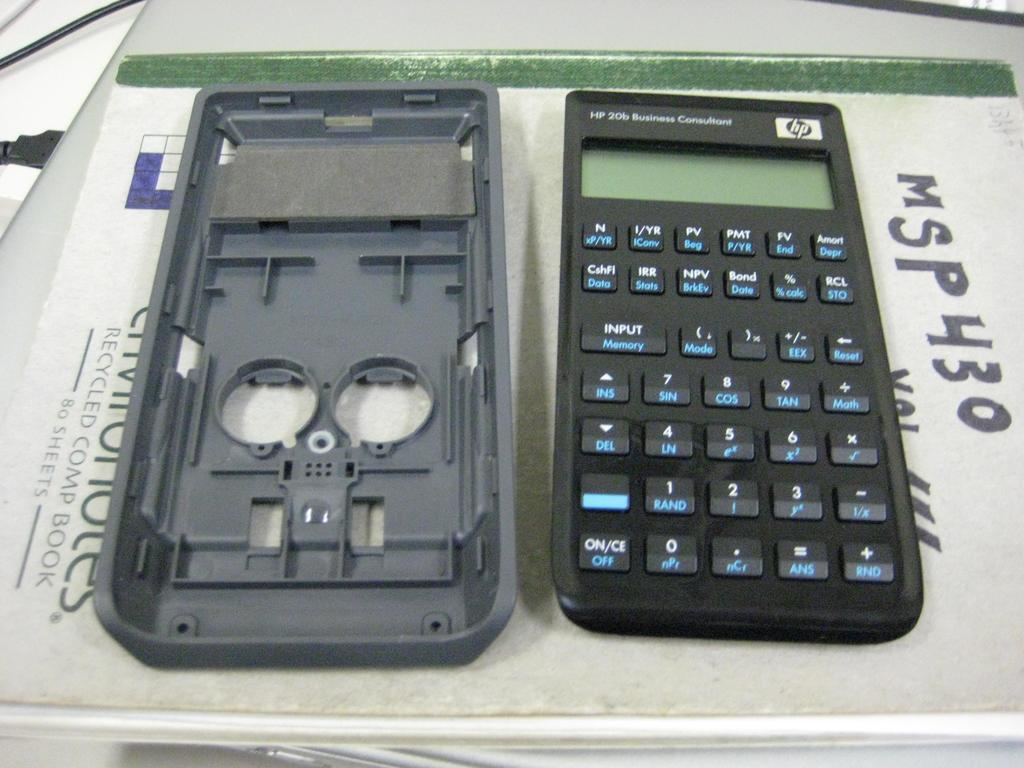<image>
Describe the image concisely. A HP Calculator with the back removed and placed next to it. 